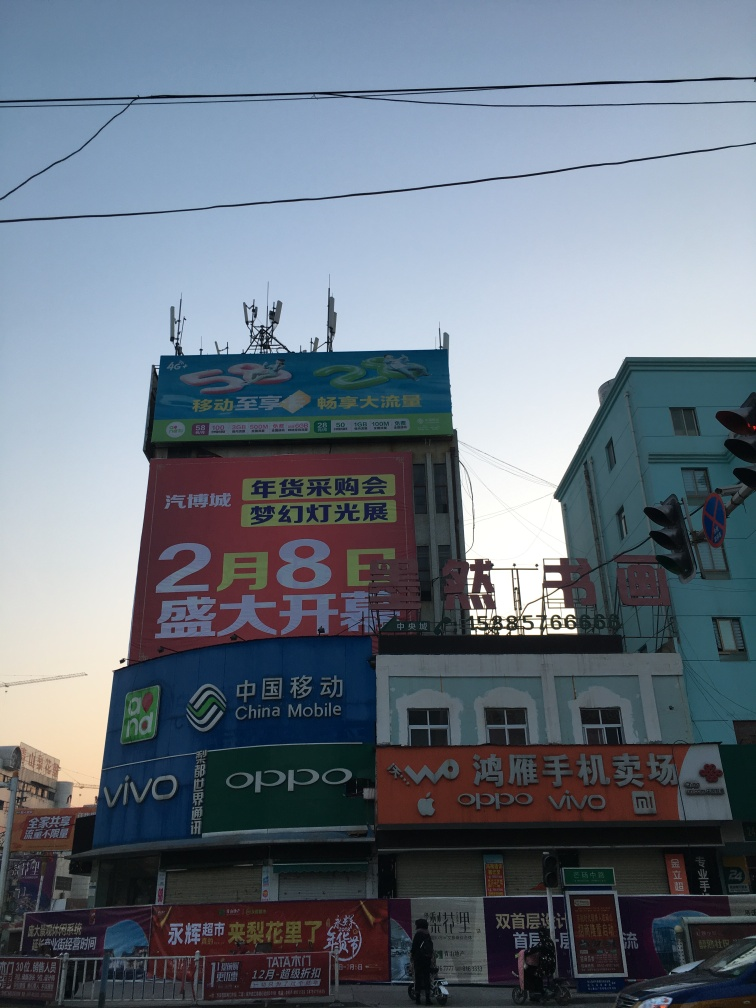Is there any indication of location or cultural context in the image? The signage contains Chinese characters, which indicates that the location is likely in a Chinese-speaking region. The presence of multiple well-known Chinese smartphone brands further suggests a commercial area in China. 